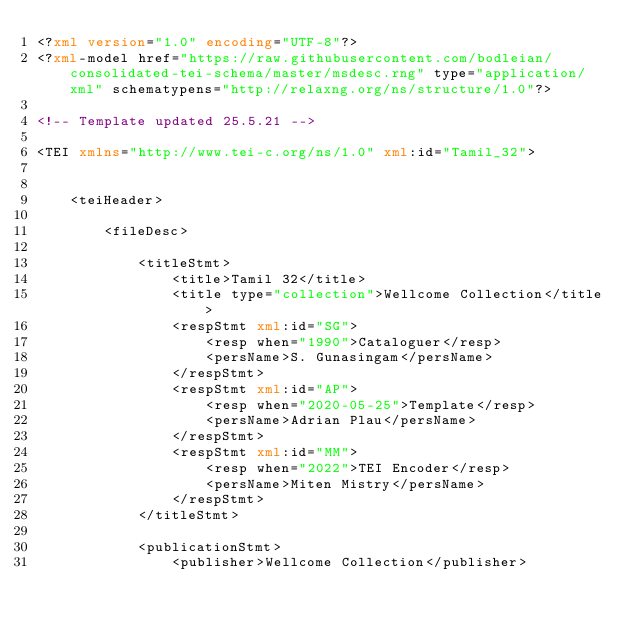Convert code to text. <code><loc_0><loc_0><loc_500><loc_500><_XML_><?xml version="1.0" encoding="UTF-8"?>
<?xml-model href="https://raw.githubusercontent.com/bodleian/consolidated-tei-schema/master/msdesc.rng" type="application/xml" schematypens="http://relaxng.org/ns/structure/1.0"?>

<!-- Template updated 25.5.21 -->

<TEI xmlns="http://www.tei-c.org/ns/1.0" xml:id="Tamil_32">
    
    
    <teiHeader>
        
        <fileDesc>
            
            <titleStmt>
                <title>Tamil 32</title>
                <title type="collection">Wellcome Collection</title>
                <respStmt xml:id="SG">
                    <resp when="1990">Cataloguer</resp>
                    <persName>S. Gunasingam</persName>
                </respStmt>
                <respStmt xml:id="AP">
                    <resp when="2020-05-25">Template</resp>
                    <persName>Adrian Plau</persName>
                </respStmt>
                <respStmt xml:id="MM">
                    <resp when="2022">TEI Encoder</resp>
                    <persName>Miten Mistry</persName>
                </respStmt>
            </titleStmt>
            
            <publicationStmt>
                <publisher>Wellcome Collection</publisher></code> 